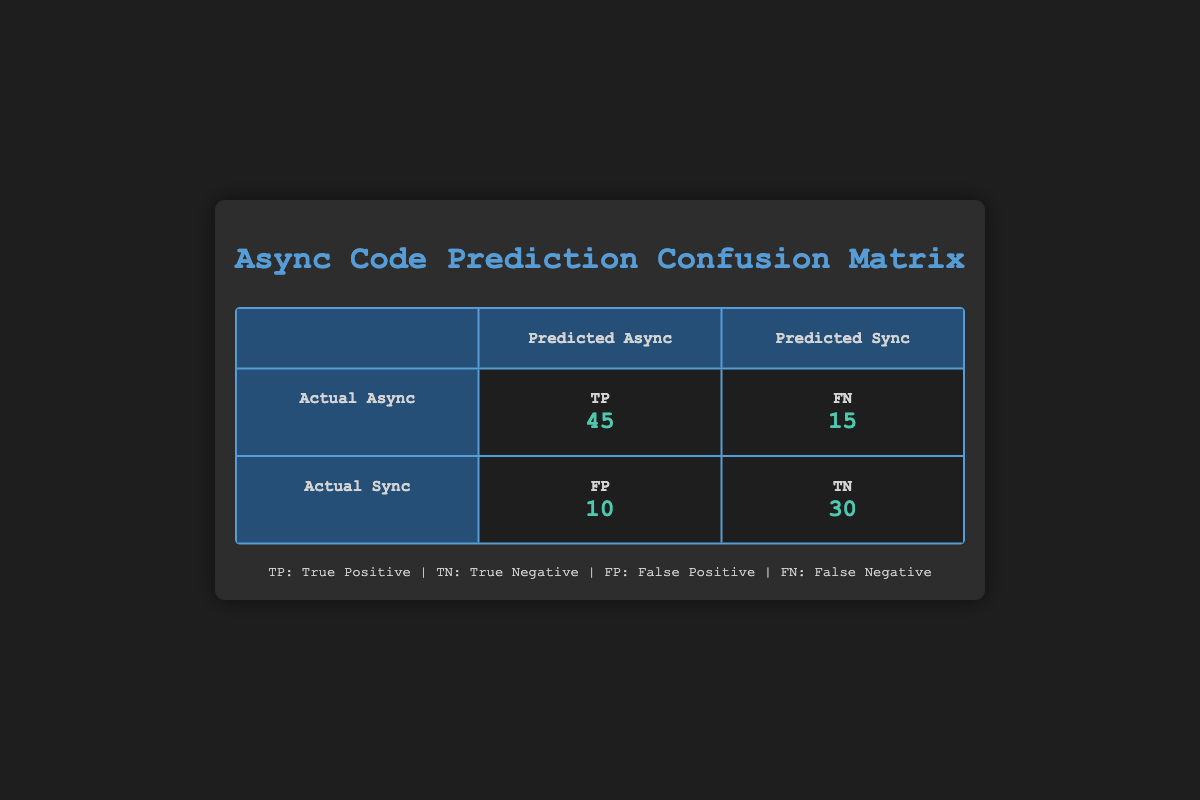What is the value of True Positives (TP) in the confusion matrix? The table directly lists True Positives (TP) as 45.
Answer: 45 What is the value of True Negatives (TN)? The table provides True Negatives (TN) as 30.
Answer: 30 How many actual asynchronous code snippets were incorrectly predicted as synchronous? This corresponds to False Negatives (FN), which is given as 15 in the table.
Answer: 15 What is the total number of code snippets evaluated in the confusion matrix? To calculate this, sum the values of TP, TN, FP, and FN: 45 + 30 + 10 + 15 = 100.
Answer: 100 What is the number of False Positives (FP) in the confusion matrix? The table lists False Positives (FP) as 10.
Answer: 10 Is the number of True Negatives greater than the number of False Positives? True Negatives (30) is greater than False Positives (10), confirming the statement as true.
Answer: Yes What are the total positives predicted by the model? To find total positives predicted, add True Positives (TP) and False Positives (FP): 45 + 10 = 55.
Answer: 55 What is the accuracy of the model? Accuracy can be calculated as (TP + TN) / Total samples: (45 + 30) / 100 = 0.75 or 75%.
Answer: 75% How many actual synchronous codes were incorrectly predicted as asynchronous? This corresponds to False Positives (FP), which is 10 in the table.
Answer: 10 What would be the total number of actual asynchronous code snippets? The total number of actual asynchronous snippets can be calculated by adding True Positives (TP) and False Negatives (FN): 45 + 15 = 60.
Answer: 60 